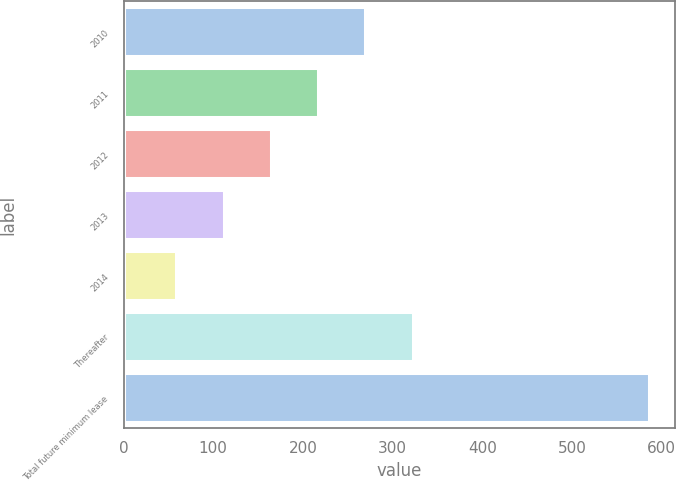Convert chart. <chart><loc_0><loc_0><loc_500><loc_500><bar_chart><fcel>2010<fcel>2011<fcel>2012<fcel>2013<fcel>2014<fcel>Thereafter<fcel>Total future minimum lease<nl><fcel>269.8<fcel>217.1<fcel>164.4<fcel>111.7<fcel>59<fcel>322.5<fcel>586<nl></chart> 